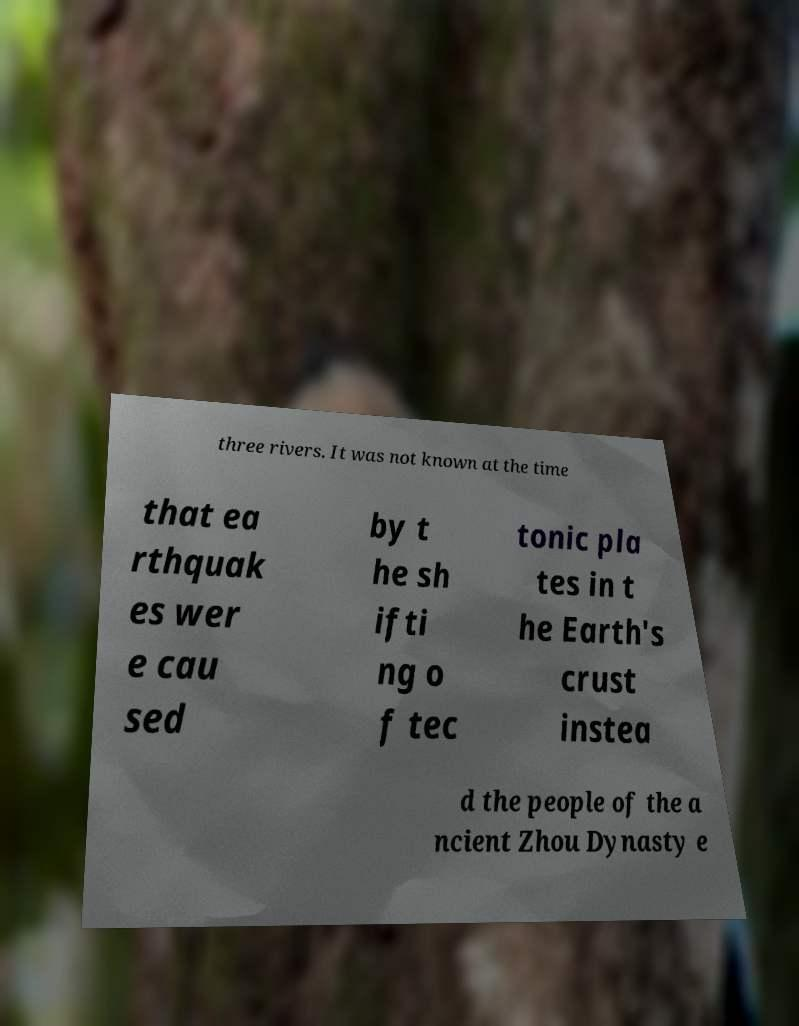Please read and relay the text visible in this image. What does it say? three rivers. It was not known at the time that ea rthquak es wer e cau sed by t he sh ifti ng o f tec tonic pla tes in t he Earth's crust instea d the people of the a ncient Zhou Dynasty e 